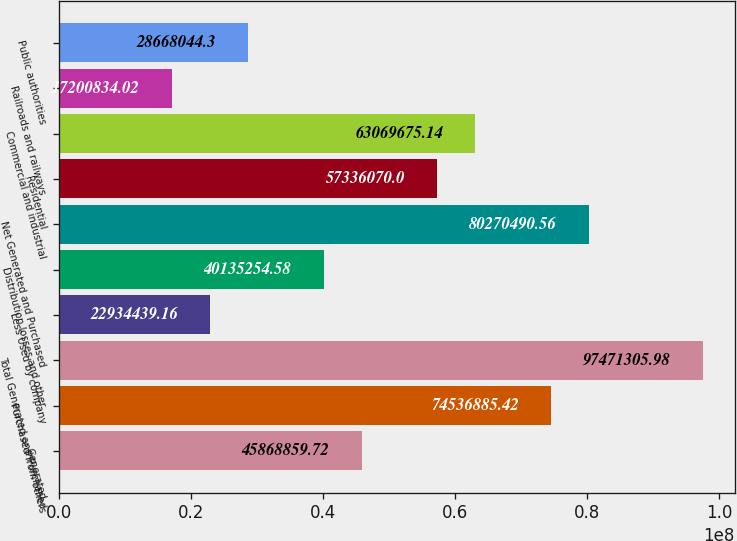Convert chart to OTSL. <chart><loc_0><loc_0><loc_500><loc_500><bar_chart><fcel>Generated<fcel>Purchased from others<fcel>Total Generated and Purchased<fcel>Less Used by company<fcel>Distribution losses and other<fcel>Net Generated and Purchased<fcel>Residential<fcel>Commercial and industrial<fcel>Railroads and railways<fcel>Public authorities<nl><fcel>4.58689e+07<fcel>7.45369e+07<fcel>9.74713e+07<fcel>2.29344e+07<fcel>4.01353e+07<fcel>8.02705e+07<fcel>5.73361e+07<fcel>6.30697e+07<fcel>1.72008e+07<fcel>2.8668e+07<nl></chart> 